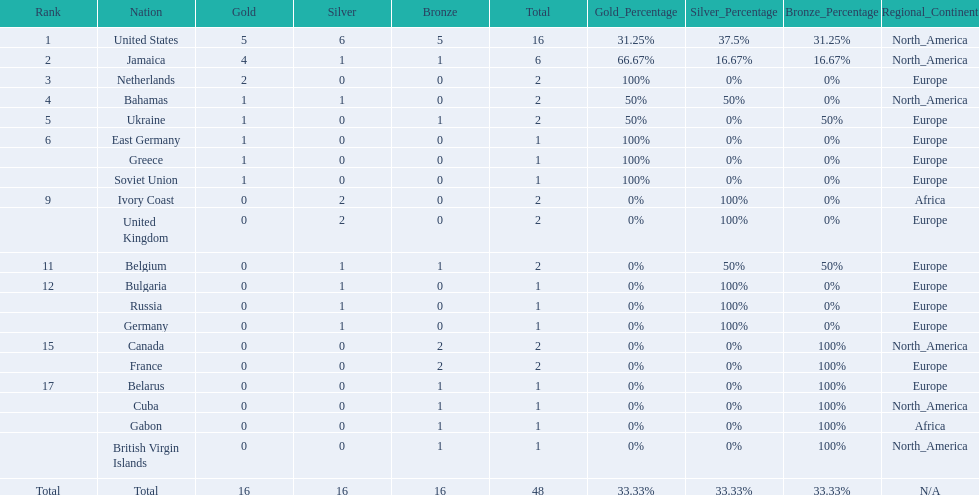What country won the most medals? United States. How many medals did the us win? 16. What is the most medals (after 16) that were won by a country? 6. Which country won 6 medals? Jamaica. 